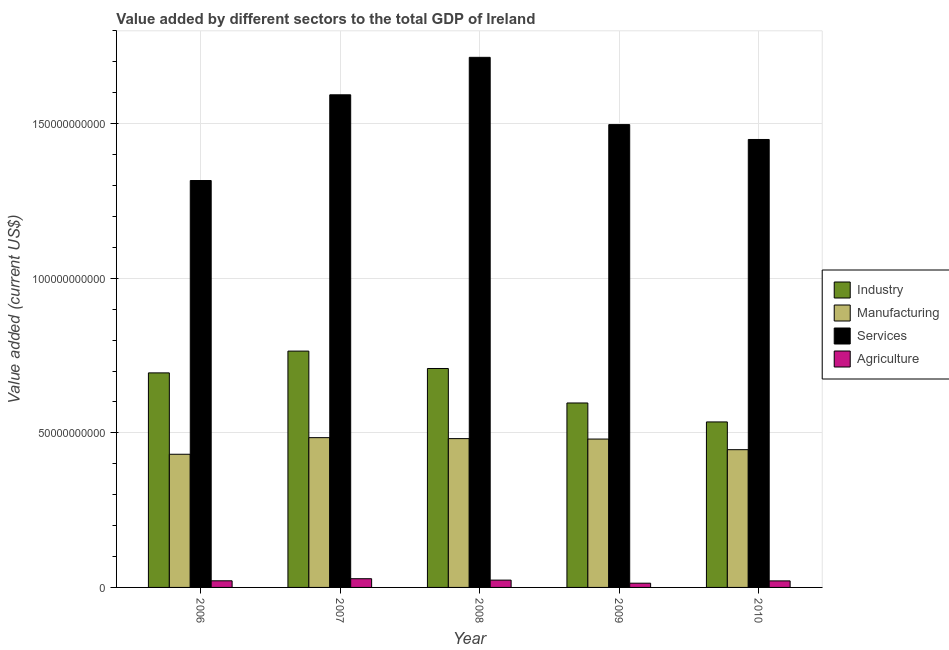How many different coloured bars are there?
Offer a very short reply. 4. What is the value added by manufacturing sector in 2007?
Provide a succinct answer. 4.84e+1. Across all years, what is the maximum value added by industrial sector?
Provide a succinct answer. 7.64e+1. Across all years, what is the minimum value added by industrial sector?
Keep it short and to the point. 5.35e+1. In which year was the value added by services sector maximum?
Ensure brevity in your answer.  2008. What is the total value added by services sector in the graph?
Give a very brief answer. 7.57e+11. What is the difference between the value added by agricultural sector in 2009 and that in 2010?
Provide a succinct answer. -7.43e+08. What is the difference between the value added by services sector in 2009 and the value added by manufacturing sector in 2007?
Your answer should be very brief. -9.64e+09. What is the average value added by services sector per year?
Keep it short and to the point. 1.51e+11. In the year 2007, what is the difference between the value added by industrial sector and value added by services sector?
Provide a short and direct response. 0. What is the ratio of the value added by manufacturing sector in 2006 to that in 2009?
Your answer should be very brief. 0.9. Is the value added by services sector in 2008 less than that in 2010?
Keep it short and to the point. No. What is the difference between the highest and the second highest value added by manufacturing sector?
Offer a terse response. 3.15e+08. What is the difference between the highest and the lowest value added by services sector?
Your answer should be compact. 3.98e+1. In how many years, is the value added by services sector greater than the average value added by services sector taken over all years?
Provide a short and direct response. 2. Is the sum of the value added by agricultural sector in 2007 and 2008 greater than the maximum value added by industrial sector across all years?
Provide a succinct answer. Yes. What does the 2nd bar from the left in 2008 represents?
Ensure brevity in your answer.  Manufacturing. What does the 2nd bar from the right in 2006 represents?
Provide a short and direct response. Services. Are all the bars in the graph horizontal?
Your response must be concise. No. How many years are there in the graph?
Your response must be concise. 5. What is the difference between two consecutive major ticks on the Y-axis?
Provide a succinct answer. 5.00e+1. Are the values on the major ticks of Y-axis written in scientific E-notation?
Make the answer very short. No. Does the graph contain any zero values?
Ensure brevity in your answer.  No. What is the title of the graph?
Your answer should be very brief. Value added by different sectors to the total GDP of Ireland. What is the label or title of the Y-axis?
Your answer should be compact. Value added (current US$). What is the Value added (current US$) in Industry in 2006?
Offer a very short reply. 6.94e+1. What is the Value added (current US$) of Manufacturing in 2006?
Provide a succinct answer. 4.31e+1. What is the Value added (current US$) in Services in 2006?
Your response must be concise. 1.32e+11. What is the Value added (current US$) of Agriculture in 2006?
Make the answer very short. 2.14e+09. What is the Value added (current US$) in Industry in 2007?
Your response must be concise. 7.64e+1. What is the Value added (current US$) in Manufacturing in 2007?
Provide a succinct answer. 4.84e+1. What is the Value added (current US$) in Services in 2007?
Make the answer very short. 1.59e+11. What is the Value added (current US$) in Agriculture in 2007?
Keep it short and to the point. 2.82e+09. What is the Value added (current US$) of Industry in 2008?
Offer a terse response. 7.08e+1. What is the Value added (current US$) in Manufacturing in 2008?
Give a very brief answer. 4.81e+1. What is the Value added (current US$) of Services in 2008?
Your answer should be very brief. 1.71e+11. What is the Value added (current US$) of Agriculture in 2008?
Keep it short and to the point. 2.37e+09. What is the Value added (current US$) in Industry in 2009?
Keep it short and to the point. 5.97e+1. What is the Value added (current US$) in Manufacturing in 2009?
Your answer should be compact. 4.80e+1. What is the Value added (current US$) in Services in 2009?
Offer a terse response. 1.50e+11. What is the Value added (current US$) of Agriculture in 2009?
Your response must be concise. 1.37e+09. What is the Value added (current US$) in Industry in 2010?
Provide a succinct answer. 5.35e+1. What is the Value added (current US$) of Manufacturing in 2010?
Provide a succinct answer. 4.46e+1. What is the Value added (current US$) in Services in 2010?
Keep it short and to the point. 1.45e+11. What is the Value added (current US$) of Agriculture in 2010?
Offer a very short reply. 2.11e+09. Across all years, what is the maximum Value added (current US$) in Industry?
Your answer should be very brief. 7.64e+1. Across all years, what is the maximum Value added (current US$) in Manufacturing?
Your response must be concise. 4.84e+1. Across all years, what is the maximum Value added (current US$) of Services?
Ensure brevity in your answer.  1.71e+11. Across all years, what is the maximum Value added (current US$) in Agriculture?
Offer a very short reply. 2.82e+09. Across all years, what is the minimum Value added (current US$) in Industry?
Your response must be concise. 5.35e+1. Across all years, what is the minimum Value added (current US$) of Manufacturing?
Your answer should be very brief. 4.31e+1. Across all years, what is the minimum Value added (current US$) in Services?
Ensure brevity in your answer.  1.32e+11. Across all years, what is the minimum Value added (current US$) in Agriculture?
Offer a very short reply. 1.37e+09. What is the total Value added (current US$) in Industry in the graph?
Your response must be concise. 3.30e+11. What is the total Value added (current US$) in Manufacturing in the graph?
Offer a terse response. 2.32e+11. What is the total Value added (current US$) of Services in the graph?
Your answer should be compact. 7.57e+11. What is the total Value added (current US$) of Agriculture in the graph?
Offer a terse response. 1.08e+1. What is the difference between the Value added (current US$) of Industry in 2006 and that in 2007?
Make the answer very short. -7.04e+09. What is the difference between the Value added (current US$) of Manufacturing in 2006 and that in 2007?
Your answer should be very brief. -5.37e+09. What is the difference between the Value added (current US$) of Services in 2006 and that in 2007?
Offer a terse response. -2.77e+1. What is the difference between the Value added (current US$) in Agriculture in 2006 and that in 2007?
Your response must be concise. -6.79e+08. What is the difference between the Value added (current US$) in Industry in 2006 and that in 2008?
Provide a short and direct response. -1.42e+09. What is the difference between the Value added (current US$) of Manufacturing in 2006 and that in 2008?
Your response must be concise. -5.06e+09. What is the difference between the Value added (current US$) in Services in 2006 and that in 2008?
Your response must be concise. -3.98e+1. What is the difference between the Value added (current US$) of Agriculture in 2006 and that in 2008?
Your answer should be very brief. -2.26e+08. What is the difference between the Value added (current US$) in Industry in 2006 and that in 2009?
Your response must be concise. 9.73e+09. What is the difference between the Value added (current US$) in Manufacturing in 2006 and that in 2009?
Your response must be concise. -4.92e+09. What is the difference between the Value added (current US$) in Services in 2006 and that in 2009?
Your answer should be compact. -1.81e+1. What is the difference between the Value added (current US$) in Agriculture in 2006 and that in 2009?
Ensure brevity in your answer.  7.73e+08. What is the difference between the Value added (current US$) of Industry in 2006 and that in 2010?
Provide a short and direct response. 1.59e+1. What is the difference between the Value added (current US$) of Manufacturing in 2006 and that in 2010?
Your response must be concise. -1.48e+09. What is the difference between the Value added (current US$) in Services in 2006 and that in 2010?
Give a very brief answer. -1.33e+1. What is the difference between the Value added (current US$) in Agriculture in 2006 and that in 2010?
Keep it short and to the point. 2.96e+07. What is the difference between the Value added (current US$) of Industry in 2007 and that in 2008?
Your answer should be very brief. 5.63e+09. What is the difference between the Value added (current US$) of Manufacturing in 2007 and that in 2008?
Offer a terse response. 3.15e+08. What is the difference between the Value added (current US$) of Services in 2007 and that in 2008?
Keep it short and to the point. -1.21e+1. What is the difference between the Value added (current US$) of Agriculture in 2007 and that in 2008?
Ensure brevity in your answer.  4.53e+08. What is the difference between the Value added (current US$) of Industry in 2007 and that in 2009?
Your answer should be compact. 1.68e+1. What is the difference between the Value added (current US$) of Manufacturing in 2007 and that in 2009?
Offer a very short reply. 4.54e+08. What is the difference between the Value added (current US$) of Services in 2007 and that in 2009?
Make the answer very short. 9.64e+09. What is the difference between the Value added (current US$) of Agriculture in 2007 and that in 2009?
Your answer should be very brief. 1.45e+09. What is the difference between the Value added (current US$) of Industry in 2007 and that in 2010?
Provide a short and direct response. 2.29e+1. What is the difference between the Value added (current US$) in Manufacturing in 2007 and that in 2010?
Your response must be concise. 3.89e+09. What is the difference between the Value added (current US$) in Services in 2007 and that in 2010?
Give a very brief answer. 1.44e+1. What is the difference between the Value added (current US$) in Agriculture in 2007 and that in 2010?
Your answer should be compact. 7.09e+08. What is the difference between the Value added (current US$) in Industry in 2008 and that in 2009?
Keep it short and to the point. 1.12e+1. What is the difference between the Value added (current US$) of Manufacturing in 2008 and that in 2009?
Give a very brief answer. 1.40e+08. What is the difference between the Value added (current US$) in Services in 2008 and that in 2009?
Give a very brief answer. 2.18e+1. What is the difference between the Value added (current US$) in Agriculture in 2008 and that in 2009?
Your answer should be very brief. 9.99e+08. What is the difference between the Value added (current US$) in Industry in 2008 and that in 2010?
Ensure brevity in your answer.  1.73e+1. What is the difference between the Value added (current US$) of Manufacturing in 2008 and that in 2010?
Keep it short and to the point. 3.58e+09. What is the difference between the Value added (current US$) in Services in 2008 and that in 2010?
Provide a short and direct response. 2.66e+1. What is the difference between the Value added (current US$) in Agriculture in 2008 and that in 2010?
Provide a short and direct response. 2.55e+08. What is the difference between the Value added (current US$) of Industry in 2009 and that in 2010?
Keep it short and to the point. 6.13e+09. What is the difference between the Value added (current US$) in Manufacturing in 2009 and that in 2010?
Offer a terse response. 3.44e+09. What is the difference between the Value added (current US$) in Services in 2009 and that in 2010?
Offer a terse response. 4.81e+09. What is the difference between the Value added (current US$) in Agriculture in 2009 and that in 2010?
Make the answer very short. -7.43e+08. What is the difference between the Value added (current US$) in Industry in 2006 and the Value added (current US$) in Manufacturing in 2007?
Offer a terse response. 2.09e+1. What is the difference between the Value added (current US$) in Industry in 2006 and the Value added (current US$) in Services in 2007?
Your answer should be very brief. -8.99e+1. What is the difference between the Value added (current US$) of Industry in 2006 and the Value added (current US$) of Agriculture in 2007?
Your answer should be compact. 6.66e+1. What is the difference between the Value added (current US$) of Manufacturing in 2006 and the Value added (current US$) of Services in 2007?
Make the answer very short. -1.16e+11. What is the difference between the Value added (current US$) in Manufacturing in 2006 and the Value added (current US$) in Agriculture in 2007?
Provide a succinct answer. 4.03e+1. What is the difference between the Value added (current US$) of Services in 2006 and the Value added (current US$) of Agriculture in 2007?
Give a very brief answer. 1.29e+11. What is the difference between the Value added (current US$) of Industry in 2006 and the Value added (current US$) of Manufacturing in 2008?
Your response must be concise. 2.13e+1. What is the difference between the Value added (current US$) of Industry in 2006 and the Value added (current US$) of Services in 2008?
Your answer should be compact. -1.02e+11. What is the difference between the Value added (current US$) in Industry in 2006 and the Value added (current US$) in Agriculture in 2008?
Ensure brevity in your answer.  6.70e+1. What is the difference between the Value added (current US$) of Manufacturing in 2006 and the Value added (current US$) of Services in 2008?
Your response must be concise. -1.28e+11. What is the difference between the Value added (current US$) in Manufacturing in 2006 and the Value added (current US$) in Agriculture in 2008?
Ensure brevity in your answer.  4.07e+1. What is the difference between the Value added (current US$) of Services in 2006 and the Value added (current US$) of Agriculture in 2008?
Ensure brevity in your answer.  1.29e+11. What is the difference between the Value added (current US$) in Industry in 2006 and the Value added (current US$) in Manufacturing in 2009?
Your answer should be very brief. 2.14e+1. What is the difference between the Value added (current US$) of Industry in 2006 and the Value added (current US$) of Services in 2009?
Your answer should be very brief. -8.03e+1. What is the difference between the Value added (current US$) of Industry in 2006 and the Value added (current US$) of Agriculture in 2009?
Make the answer very short. 6.80e+1. What is the difference between the Value added (current US$) of Manufacturing in 2006 and the Value added (current US$) of Services in 2009?
Your response must be concise. -1.07e+11. What is the difference between the Value added (current US$) of Manufacturing in 2006 and the Value added (current US$) of Agriculture in 2009?
Offer a terse response. 4.17e+1. What is the difference between the Value added (current US$) in Services in 2006 and the Value added (current US$) in Agriculture in 2009?
Ensure brevity in your answer.  1.30e+11. What is the difference between the Value added (current US$) in Industry in 2006 and the Value added (current US$) in Manufacturing in 2010?
Your answer should be very brief. 2.48e+1. What is the difference between the Value added (current US$) of Industry in 2006 and the Value added (current US$) of Services in 2010?
Your answer should be compact. -7.55e+1. What is the difference between the Value added (current US$) of Industry in 2006 and the Value added (current US$) of Agriculture in 2010?
Your answer should be very brief. 6.73e+1. What is the difference between the Value added (current US$) of Manufacturing in 2006 and the Value added (current US$) of Services in 2010?
Ensure brevity in your answer.  -1.02e+11. What is the difference between the Value added (current US$) of Manufacturing in 2006 and the Value added (current US$) of Agriculture in 2010?
Provide a succinct answer. 4.10e+1. What is the difference between the Value added (current US$) in Services in 2006 and the Value added (current US$) in Agriculture in 2010?
Make the answer very short. 1.29e+11. What is the difference between the Value added (current US$) in Industry in 2007 and the Value added (current US$) in Manufacturing in 2008?
Make the answer very short. 2.83e+1. What is the difference between the Value added (current US$) of Industry in 2007 and the Value added (current US$) of Services in 2008?
Offer a very short reply. -9.50e+1. What is the difference between the Value added (current US$) in Industry in 2007 and the Value added (current US$) in Agriculture in 2008?
Offer a terse response. 7.41e+1. What is the difference between the Value added (current US$) in Manufacturing in 2007 and the Value added (current US$) in Services in 2008?
Give a very brief answer. -1.23e+11. What is the difference between the Value added (current US$) of Manufacturing in 2007 and the Value added (current US$) of Agriculture in 2008?
Provide a short and direct response. 4.61e+1. What is the difference between the Value added (current US$) of Services in 2007 and the Value added (current US$) of Agriculture in 2008?
Your response must be concise. 1.57e+11. What is the difference between the Value added (current US$) of Industry in 2007 and the Value added (current US$) of Manufacturing in 2009?
Give a very brief answer. 2.84e+1. What is the difference between the Value added (current US$) in Industry in 2007 and the Value added (current US$) in Services in 2009?
Ensure brevity in your answer.  -7.33e+1. What is the difference between the Value added (current US$) of Industry in 2007 and the Value added (current US$) of Agriculture in 2009?
Offer a terse response. 7.51e+1. What is the difference between the Value added (current US$) in Manufacturing in 2007 and the Value added (current US$) in Services in 2009?
Provide a succinct answer. -1.01e+11. What is the difference between the Value added (current US$) in Manufacturing in 2007 and the Value added (current US$) in Agriculture in 2009?
Keep it short and to the point. 4.71e+1. What is the difference between the Value added (current US$) in Services in 2007 and the Value added (current US$) in Agriculture in 2009?
Keep it short and to the point. 1.58e+11. What is the difference between the Value added (current US$) in Industry in 2007 and the Value added (current US$) in Manufacturing in 2010?
Provide a succinct answer. 3.19e+1. What is the difference between the Value added (current US$) in Industry in 2007 and the Value added (current US$) in Services in 2010?
Your answer should be very brief. -6.85e+1. What is the difference between the Value added (current US$) of Industry in 2007 and the Value added (current US$) of Agriculture in 2010?
Give a very brief answer. 7.43e+1. What is the difference between the Value added (current US$) of Manufacturing in 2007 and the Value added (current US$) of Services in 2010?
Offer a terse response. -9.64e+1. What is the difference between the Value added (current US$) of Manufacturing in 2007 and the Value added (current US$) of Agriculture in 2010?
Your answer should be compact. 4.63e+1. What is the difference between the Value added (current US$) in Services in 2007 and the Value added (current US$) in Agriculture in 2010?
Your answer should be compact. 1.57e+11. What is the difference between the Value added (current US$) in Industry in 2008 and the Value added (current US$) in Manufacturing in 2009?
Offer a very short reply. 2.28e+1. What is the difference between the Value added (current US$) of Industry in 2008 and the Value added (current US$) of Services in 2009?
Your answer should be very brief. -7.89e+1. What is the difference between the Value added (current US$) in Industry in 2008 and the Value added (current US$) in Agriculture in 2009?
Provide a short and direct response. 6.94e+1. What is the difference between the Value added (current US$) of Manufacturing in 2008 and the Value added (current US$) of Services in 2009?
Make the answer very short. -1.02e+11. What is the difference between the Value added (current US$) in Manufacturing in 2008 and the Value added (current US$) in Agriculture in 2009?
Make the answer very short. 4.68e+1. What is the difference between the Value added (current US$) in Services in 2008 and the Value added (current US$) in Agriculture in 2009?
Your answer should be very brief. 1.70e+11. What is the difference between the Value added (current US$) of Industry in 2008 and the Value added (current US$) of Manufacturing in 2010?
Provide a succinct answer. 2.63e+1. What is the difference between the Value added (current US$) in Industry in 2008 and the Value added (current US$) in Services in 2010?
Provide a short and direct response. -7.41e+1. What is the difference between the Value added (current US$) in Industry in 2008 and the Value added (current US$) in Agriculture in 2010?
Provide a short and direct response. 6.87e+1. What is the difference between the Value added (current US$) in Manufacturing in 2008 and the Value added (current US$) in Services in 2010?
Provide a short and direct response. -9.68e+1. What is the difference between the Value added (current US$) in Manufacturing in 2008 and the Value added (current US$) in Agriculture in 2010?
Offer a terse response. 4.60e+1. What is the difference between the Value added (current US$) of Services in 2008 and the Value added (current US$) of Agriculture in 2010?
Your response must be concise. 1.69e+11. What is the difference between the Value added (current US$) in Industry in 2009 and the Value added (current US$) in Manufacturing in 2010?
Your answer should be compact. 1.51e+1. What is the difference between the Value added (current US$) of Industry in 2009 and the Value added (current US$) of Services in 2010?
Offer a terse response. -8.52e+1. What is the difference between the Value added (current US$) of Industry in 2009 and the Value added (current US$) of Agriculture in 2010?
Your response must be concise. 5.75e+1. What is the difference between the Value added (current US$) in Manufacturing in 2009 and the Value added (current US$) in Services in 2010?
Your response must be concise. -9.69e+1. What is the difference between the Value added (current US$) in Manufacturing in 2009 and the Value added (current US$) in Agriculture in 2010?
Provide a short and direct response. 4.59e+1. What is the difference between the Value added (current US$) of Services in 2009 and the Value added (current US$) of Agriculture in 2010?
Keep it short and to the point. 1.48e+11. What is the average Value added (current US$) in Industry per year?
Give a very brief answer. 6.60e+1. What is the average Value added (current US$) in Manufacturing per year?
Offer a very short reply. 4.64e+1. What is the average Value added (current US$) in Services per year?
Provide a succinct answer. 1.51e+11. What is the average Value added (current US$) of Agriculture per year?
Provide a short and direct response. 2.16e+09. In the year 2006, what is the difference between the Value added (current US$) of Industry and Value added (current US$) of Manufacturing?
Your response must be concise. 2.63e+1. In the year 2006, what is the difference between the Value added (current US$) in Industry and Value added (current US$) in Services?
Your answer should be compact. -6.22e+1. In the year 2006, what is the difference between the Value added (current US$) of Industry and Value added (current US$) of Agriculture?
Give a very brief answer. 6.73e+1. In the year 2006, what is the difference between the Value added (current US$) of Manufacturing and Value added (current US$) of Services?
Provide a succinct answer. -8.85e+1. In the year 2006, what is the difference between the Value added (current US$) of Manufacturing and Value added (current US$) of Agriculture?
Your answer should be very brief. 4.09e+1. In the year 2006, what is the difference between the Value added (current US$) of Services and Value added (current US$) of Agriculture?
Your answer should be compact. 1.29e+11. In the year 2007, what is the difference between the Value added (current US$) in Industry and Value added (current US$) in Manufacturing?
Give a very brief answer. 2.80e+1. In the year 2007, what is the difference between the Value added (current US$) in Industry and Value added (current US$) in Services?
Provide a short and direct response. -8.29e+1. In the year 2007, what is the difference between the Value added (current US$) of Industry and Value added (current US$) of Agriculture?
Provide a short and direct response. 7.36e+1. In the year 2007, what is the difference between the Value added (current US$) in Manufacturing and Value added (current US$) in Services?
Your response must be concise. -1.11e+11. In the year 2007, what is the difference between the Value added (current US$) in Manufacturing and Value added (current US$) in Agriculture?
Your answer should be compact. 4.56e+1. In the year 2007, what is the difference between the Value added (current US$) in Services and Value added (current US$) in Agriculture?
Provide a succinct answer. 1.57e+11. In the year 2008, what is the difference between the Value added (current US$) in Industry and Value added (current US$) in Manufacturing?
Provide a succinct answer. 2.27e+1. In the year 2008, what is the difference between the Value added (current US$) in Industry and Value added (current US$) in Services?
Your response must be concise. -1.01e+11. In the year 2008, what is the difference between the Value added (current US$) in Industry and Value added (current US$) in Agriculture?
Provide a succinct answer. 6.84e+1. In the year 2008, what is the difference between the Value added (current US$) of Manufacturing and Value added (current US$) of Services?
Keep it short and to the point. -1.23e+11. In the year 2008, what is the difference between the Value added (current US$) of Manufacturing and Value added (current US$) of Agriculture?
Ensure brevity in your answer.  4.58e+1. In the year 2008, what is the difference between the Value added (current US$) in Services and Value added (current US$) in Agriculture?
Keep it short and to the point. 1.69e+11. In the year 2009, what is the difference between the Value added (current US$) in Industry and Value added (current US$) in Manufacturing?
Your answer should be very brief. 1.17e+1. In the year 2009, what is the difference between the Value added (current US$) in Industry and Value added (current US$) in Services?
Your answer should be compact. -9.00e+1. In the year 2009, what is the difference between the Value added (current US$) of Industry and Value added (current US$) of Agriculture?
Provide a succinct answer. 5.83e+1. In the year 2009, what is the difference between the Value added (current US$) in Manufacturing and Value added (current US$) in Services?
Provide a short and direct response. -1.02e+11. In the year 2009, what is the difference between the Value added (current US$) of Manufacturing and Value added (current US$) of Agriculture?
Ensure brevity in your answer.  4.66e+1. In the year 2009, what is the difference between the Value added (current US$) in Services and Value added (current US$) in Agriculture?
Keep it short and to the point. 1.48e+11. In the year 2010, what is the difference between the Value added (current US$) in Industry and Value added (current US$) in Manufacturing?
Make the answer very short. 8.97e+09. In the year 2010, what is the difference between the Value added (current US$) of Industry and Value added (current US$) of Services?
Your answer should be very brief. -9.14e+1. In the year 2010, what is the difference between the Value added (current US$) in Industry and Value added (current US$) in Agriculture?
Make the answer very short. 5.14e+1. In the year 2010, what is the difference between the Value added (current US$) of Manufacturing and Value added (current US$) of Services?
Your answer should be very brief. -1.00e+11. In the year 2010, what is the difference between the Value added (current US$) of Manufacturing and Value added (current US$) of Agriculture?
Provide a short and direct response. 4.24e+1. In the year 2010, what is the difference between the Value added (current US$) of Services and Value added (current US$) of Agriculture?
Make the answer very short. 1.43e+11. What is the ratio of the Value added (current US$) in Industry in 2006 to that in 2007?
Give a very brief answer. 0.91. What is the ratio of the Value added (current US$) in Manufacturing in 2006 to that in 2007?
Provide a succinct answer. 0.89. What is the ratio of the Value added (current US$) of Services in 2006 to that in 2007?
Provide a succinct answer. 0.83. What is the ratio of the Value added (current US$) of Agriculture in 2006 to that in 2007?
Your answer should be very brief. 0.76. What is the ratio of the Value added (current US$) in Industry in 2006 to that in 2008?
Offer a very short reply. 0.98. What is the ratio of the Value added (current US$) of Manufacturing in 2006 to that in 2008?
Provide a succinct answer. 0.89. What is the ratio of the Value added (current US$) in Services in 2006 to that in 2008?
Offer a very short reply. 0.77. What is the ratio of the Value added (current US$) of Agriculture in 2006 to that in 2008?
Your response must be concise. 0.9. What is the ratio of the Value added (current US$) in Industry in 2006 to that in 2009?
Offer a very short reply. 1.16. What is the ratio of the Value added (current US$) of Manufacturing in 2006 to that in 2009?
Offer a terse response. 0.9. What is the ratio of the Value added (current US$) of Services in 2006 to that in 2009?
Your answer should be very brief. 0.88. What is the ratio of the Value added (current US$) of Agriculture in 2006 to that in 2009?
Provide a succinct answer. 1.57. What is the ratio of the Value added (current US$) of Industry in 2006 to that in 2010?
Ensure brevity in your answer.  1.3. What is the ratio of the Value added (current US$) in Manufacturing in 2006 to that in 2010?
Give a very brief answer. 0.97. What is the ratio of the Value added (current US$) of Services in 2006 to that in 2010?
Provide a short and direct response. 0.91. What is the ratio of the Value added (current US$) in Industry in 2007 to that in 2008?
Your answer should be compact. 1.08. What is the ratio of the Value added (current US$) of Services in 2007 to that in 2008?
Your answer should be very brief. 0.93. What is the ratio of the Value added (current US$) of Agriculture in 2007 to that in 2008?
Provide a succinct answer. 1.19. What is the ratio of the Value added (current US$) in Industry in 2007 to that in 2009?
Make the answer very short. 1.28. What is the ratio of the Value added (current US$) in Manufacturing in 2007 to that in 2009?
Give a very brief answer. 1.01. What is the ratio of the Value added (current US$) of Services in 2007 to that in 2009?
Provide a succinct answer. 1.06. What is the ratio of the Value added (current US$) in Agriculture in 2007 to that in 2009?
Ensure brevity in your answer.  2.06. What is the ratio of the Value added (current US$) of Industry in 2007 to that in 2010?
Your answer should be compact. 1.43. What is the ratio of the Value added (current US$) in Manufacturing in 2007 to that in 2010?
Offer a terse response. 1.09. What is the ratio of the Value added (current US$) of Services in 2007 to that in 2010?
Ensure brevity in your answer.  1.1. What is the ratio of the Value added (current US$) in Agriculture in 2007 to that in 2010?
Your answer should be compact. 1.34. What is the ratio of the Value added (current US$) in Industry in 2008 to that in 2009?
Your answer should be very brief. 1.19. What is the ratio of the Value added (current US$) of Manufacturing in 2008 to that in 2009?
Give a very brief answer. 1. What is the ratio of the Value added (current US$) of Services in 2008 to that in 2009?
Offer a terse response. 1.15. What is the ratio of the Value added (current US$) of Agriculture in 2008 to that in 2009?
Your answer should be compact. 1.73. What is the ratio of the Value added (current US$) of Industry in 2008 to that in 2010?
Provide a succinct answer. 1.32. What is the ratio of the Value added (current US$) of Manufacturing in 2008 to that in 2010?
Provide a succinct answer. 1.08. What is the ratio of the Value added (current US$) of Services in 2008 to that in 2010?
Make the answer very short. 1.18. What is the ratio of the Value added (current US$) of Agriculture in 2008 to that in 2010?
Provide a succinct answer. 1.12. What is the ratio of the Value added (current US$) in Industry in 2009 to that in 2010?
Provide a short and direct response. 1.11. What is the ratio of the Value added (current US$) in Manufacturing in 2009 to that in 2010?
Your answer should be very brief. 1.08. What is the ratio of the Value added (current US$) of Services in 2009 to that in 2010?
Give a very brief answer. 1.03. What is the ratio of the Value added (current US$) of Agriculture in 2009 to that in 2010?
Provide a succinct answer. 0.65. What is the difference between the highest and the second highest Value added (current US$) of Industry?
Offer a very short reply. 5.63e+09. What is the difference between the highest and the second highest Value added (current US$) in Manufacturing?
Provide a short and direct response. 3.15e+08. What is the difference between the highest and the second highest Value added (current US$) of Services?
Ensure brevity in your answer.  1.21e+1. What is the difference between the highest and the second highest Value added (current US$) of Agriculture?
Your response must be concise. 4.53e+08. What is the difference between the highest and the lowest Value added (current US$) in Industry?
Offer a very short reply. 2.29e+1. What is the difference between the highest and the lowest Value added (current US$) of Manufacturing?
Keep it short and to the point. 5.37e+09. What is the difference between the highest and the lowest Value added (current US$) in Services?
Provide a succinct answer. 3.98e+1. What is the difference between the highest and the lowest Value added (current US$) in Agriculture?
Ensure brevity in your answer.  1.45e+09. 